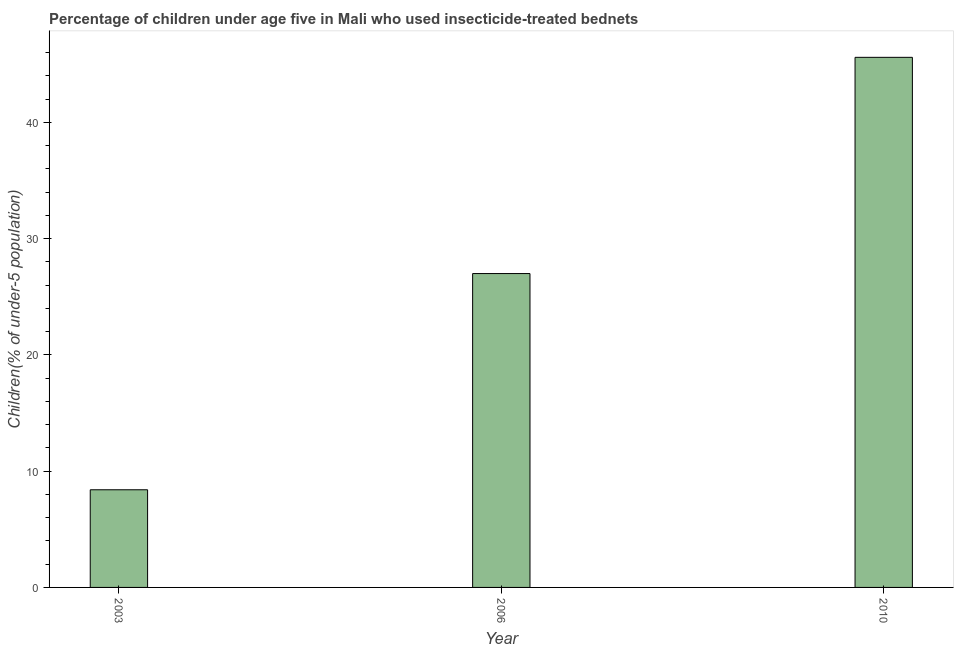What is the title of the graph?
Make the answer very short. Percentage of children under age five in Mali who used insecticide-treated bednets. What is the label or title of the Y-axis?
Your response must be concise. Children(% of under-5 population). What is the percentage of children who use of insecticide-treated bed nets in 2010?
Provide a short and direct response. 45.6. Across all years, what is the maximum percentage of children who use of insecticide-treated bed nets?
Ensure brevity in your answer.  45.6. Across all years, what is the minimum percentage of children who use of insecticide-treated bed nets?
Give a very brief answer. 8.4. In which year was the percentage of children who use of insecticide-treated bed nets maximum?
Offer a terse response. 2010. What is the sum of the percentage of children who use of insecticide-treated bed nets?
Give a very brief answer. 81. What is the difference between the percentage of children who use of insecticide-treated bed nets in 2003 and 2006?
Provide a short and direct response. -18.6. What is the median percentage of children who use of insecticide-treated bed nets?
Make the answer very short. 27. Do a majority of the years between 2003 and 2006 (inclusive) have percentage of children who use of insecticide-treated bed nets greater than 10 %?
Make the answer very short. No. What is the ratio of the percentage of children who use of insecticide-treated bed nets in 2003 to that in 2006?
Provide a short and direct response. 0.31. What is the difference between the highest and the second highest percentage of children who use of insecticide-treated bed nets?
Offer a terse response. 18.6. Is the sum of the percentage of children who use of insecticide-treated bed nets in 2006 and 2010 greater than the maximum percentage of children who use of insecticide-treated bed nets across all years?
Give a very brief answer. Yes. What is the difference between the highest and the lowest percentage of children who use of insecticide-treated bed nets?
Give a very brief answer. 37.2. In how many years, is the percentage of children who use of insecticide-treated bed nets greater than the average percentage of children who use of insecticide-treated bed nets taken over all years?
Ensure brevity in your answer.  2. What is the difference between two consecutive major ticks on the Y-axis?
Your answer should be very brief. 10. What is the Children(% of under-5 population) of 2003?
Make the answer very short. 8.4. What is the Children(% of under-5 population) of 2010?
Your response must be concise. 45.6. What is the difference between the Children(% of under-5 population) in 2003 and 2006?
Offer a terse response. -18.6. What is the difference between the Children(% of under-5 population) in 2003 and 2010?
Provide a short and direct response. -37.2. What is the difference between the Children(% of under-5 population) in 2006 and 2010?
Your answer should be very brief. -18.6. What is the ratio of the Children(% of under-5 population) in 2003 to that in 2006?
Provide a succinct answer. 0.31. What is the ratio of the Children(% of under-5 population) in 2003 to that in 2010?
Your response must be concise. 0.18. What is the ratio of the Children(% of under-5 population) in 2006 to that in 2010?
Your answer should be very brief. 0.59. 